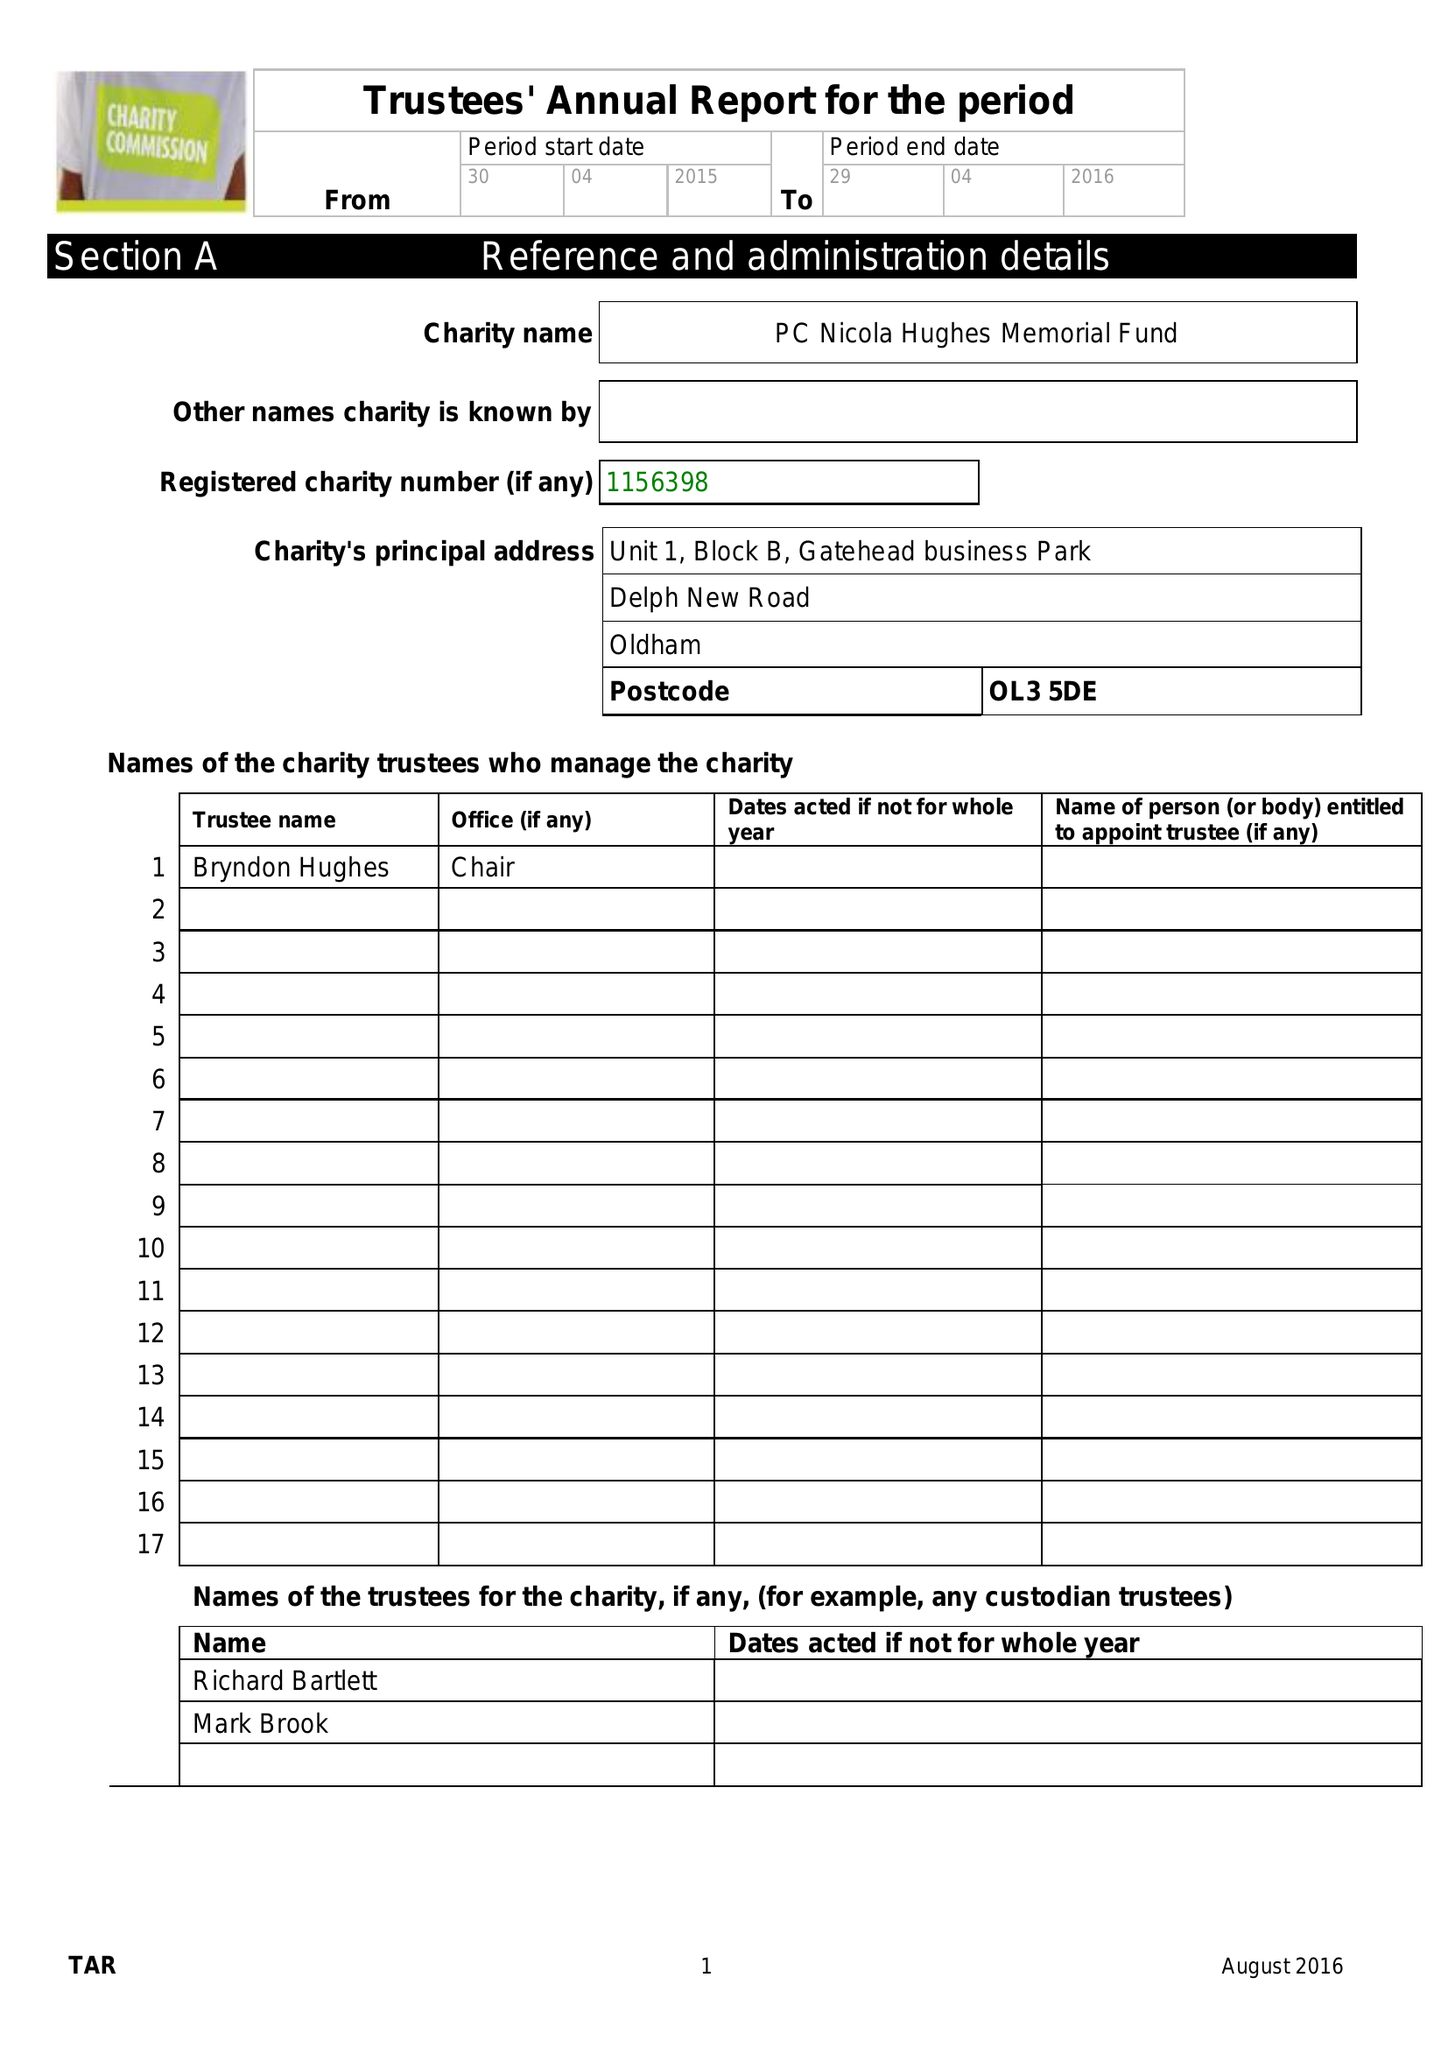What is the value for the spending_annually_in_british_pounds?
Answer the question using a single word or phrase. 43497.00 